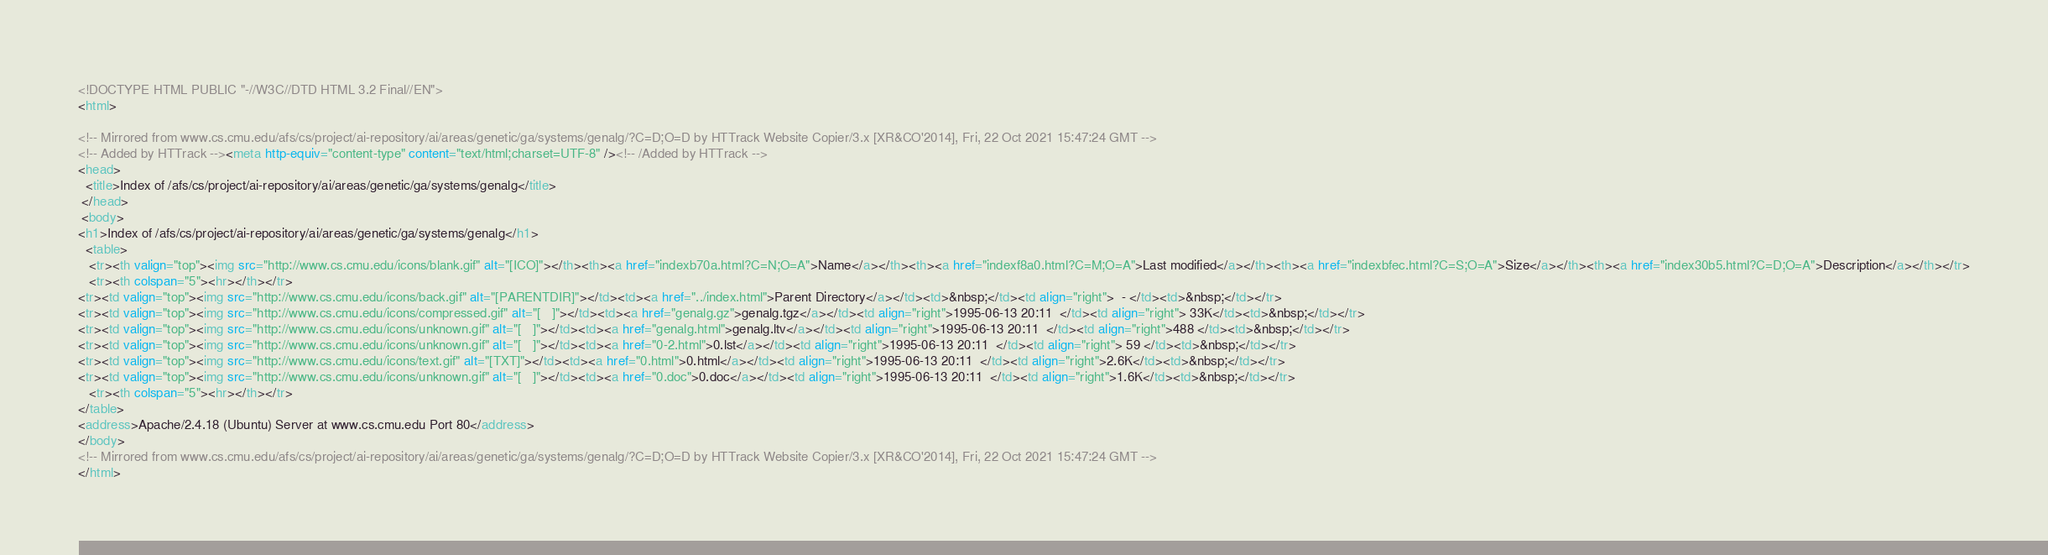Convert code to text. <code><loc_0><loc_0><loc_500><loc_500><_HTML_><!DOCTYPE HTML PUBLIC "-//W3C//DTD HTML 3.2 Final//EN">
<html>
 
<!-- Mirrored from www.cs.cmu.edu/afs/cs/project/ai-repository/ai/areas/genetic/ga/systems/genalg/?C=D;O=D by HTTrack Website Copier/3.x [XR&CO'2014], Fri, 22 Oct 2021 15:47:24 GMT -->
<!-- Added by HTTrack --><meta http-equiv="content-type" content="text/html;charset=UTF-8" /><!-- /Added by HTTrack -->
<head>
  <title>Index of /afs/cs/project/ai-repository/ai/areas/genetic/ga/systems/genalg</title>
 </head>
 <body>
<h1>Index of /afs/cs/project/ai-repository/ai/areas/genetic/ga/systems/genalg</h1>
  <table>
   <tr><th valign="top"><img src="http://www.cs.cmu.edu/icons/blank.gif" alt="[ICO]"></th><th><a href="indexb70a.html?C=N;O=A">Name</a></th><th><a href="indexf8a0.html?C=M;O=A">Last modified</a></th><th><a href="indexbfec.html?C=S;O=A">Size</a></th><th><a href="index30b5.html?C=D;O=A">Description</a></th></tr>
   <tr><th colspan="5"><hr></th></tr>
<tr><td valign="top"><img src="http://www.cs.cmu.edu/icons/back.gif" alt="[PARENTDIR]"></td><td><a href="../index.html">Parent Directory</a></td><td>&nbsp;</td><td align="right">  - </td><td>&nbsp;</td></tr>
<tr><td valign="top"><img src="http://www.cs.cmu.edu/icons/compressed.gif" alt="[   ]"></td><td><a href="genalg.gz">genalg.tgz</a></td><td align="right">1995-06-13 20:11  </td><td align="right"> 33K</td><td>&nbsp;</td></tr>
<tr><td valign="top"><img src="http://www.cs.cmu.edu/icons/unknown.gif" alt="[   ]"></td><td><a href="genalg.html">genalg.ltv</a></td><td align="right">1995-06-13 20:11  </td><td align="right">488 </td><td>&nbsp;</td></tr>
<tr><td valign="top"><img src="http://www.cs.cmu.edu/icons/unknown.gif" alt="[   ]"></td><td><a href="0-2.html">0.lst</a></td><td align="right">1995-06-13 20:11  </td><td align="right"> 59 </td><td>&nbsp;</td></tr>
<tr><td valign="top"><img src="http://www.cs.cmu.edu/icons/text.gif" alt="[TXT]"></td><td><a href="0.html">0.html</a></td><td align="right">1995-06-13 20:11  </td><td align="right">2.6K</td><td>&nbsp;</td></tr>
<tr><td valign="top"><img src="http://www.cs.cmu.edu/icons/unknown.gif" alt="[   ]"></td><td><a href="0.doc">0.doc</a></td><td align="right">1995-06-13 20:11  </td><td align="right">1.6K</td><td>&nbsp;</td></tr>
   <tr><th colspan="5"><hr></th></tr>
</table>
<address>Apache/2.4.18 (Ubuntu) Server at www.cs.cmu.edu Port 80</address>
</body>
<!-- Mirrored from www.cs.cmu.edu/afs/cs/project/ai-repository/ai/areas/genetic/ga/systems/genalg/?C=D;O=D by HTTrack Website Copier/3.x [XR&CO'2014], Fri, 22 Oct 2021 15:47:24 GMT -->
</html>
</code> 